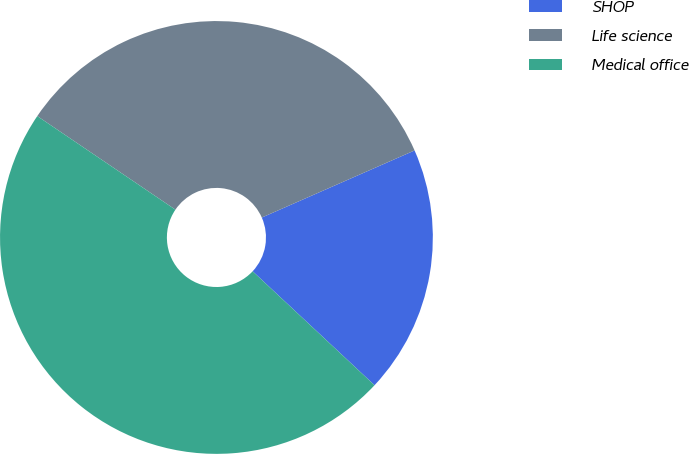Convert chart. <chart><loc_0><loc_0><loc_500><loc_500><pie_chart><fcel>SHOP<fcel>Life science<fcel>Medical office<nl><fcel>18.55%<fcel>33.94%<fcel>47.52%<nl></chart> 